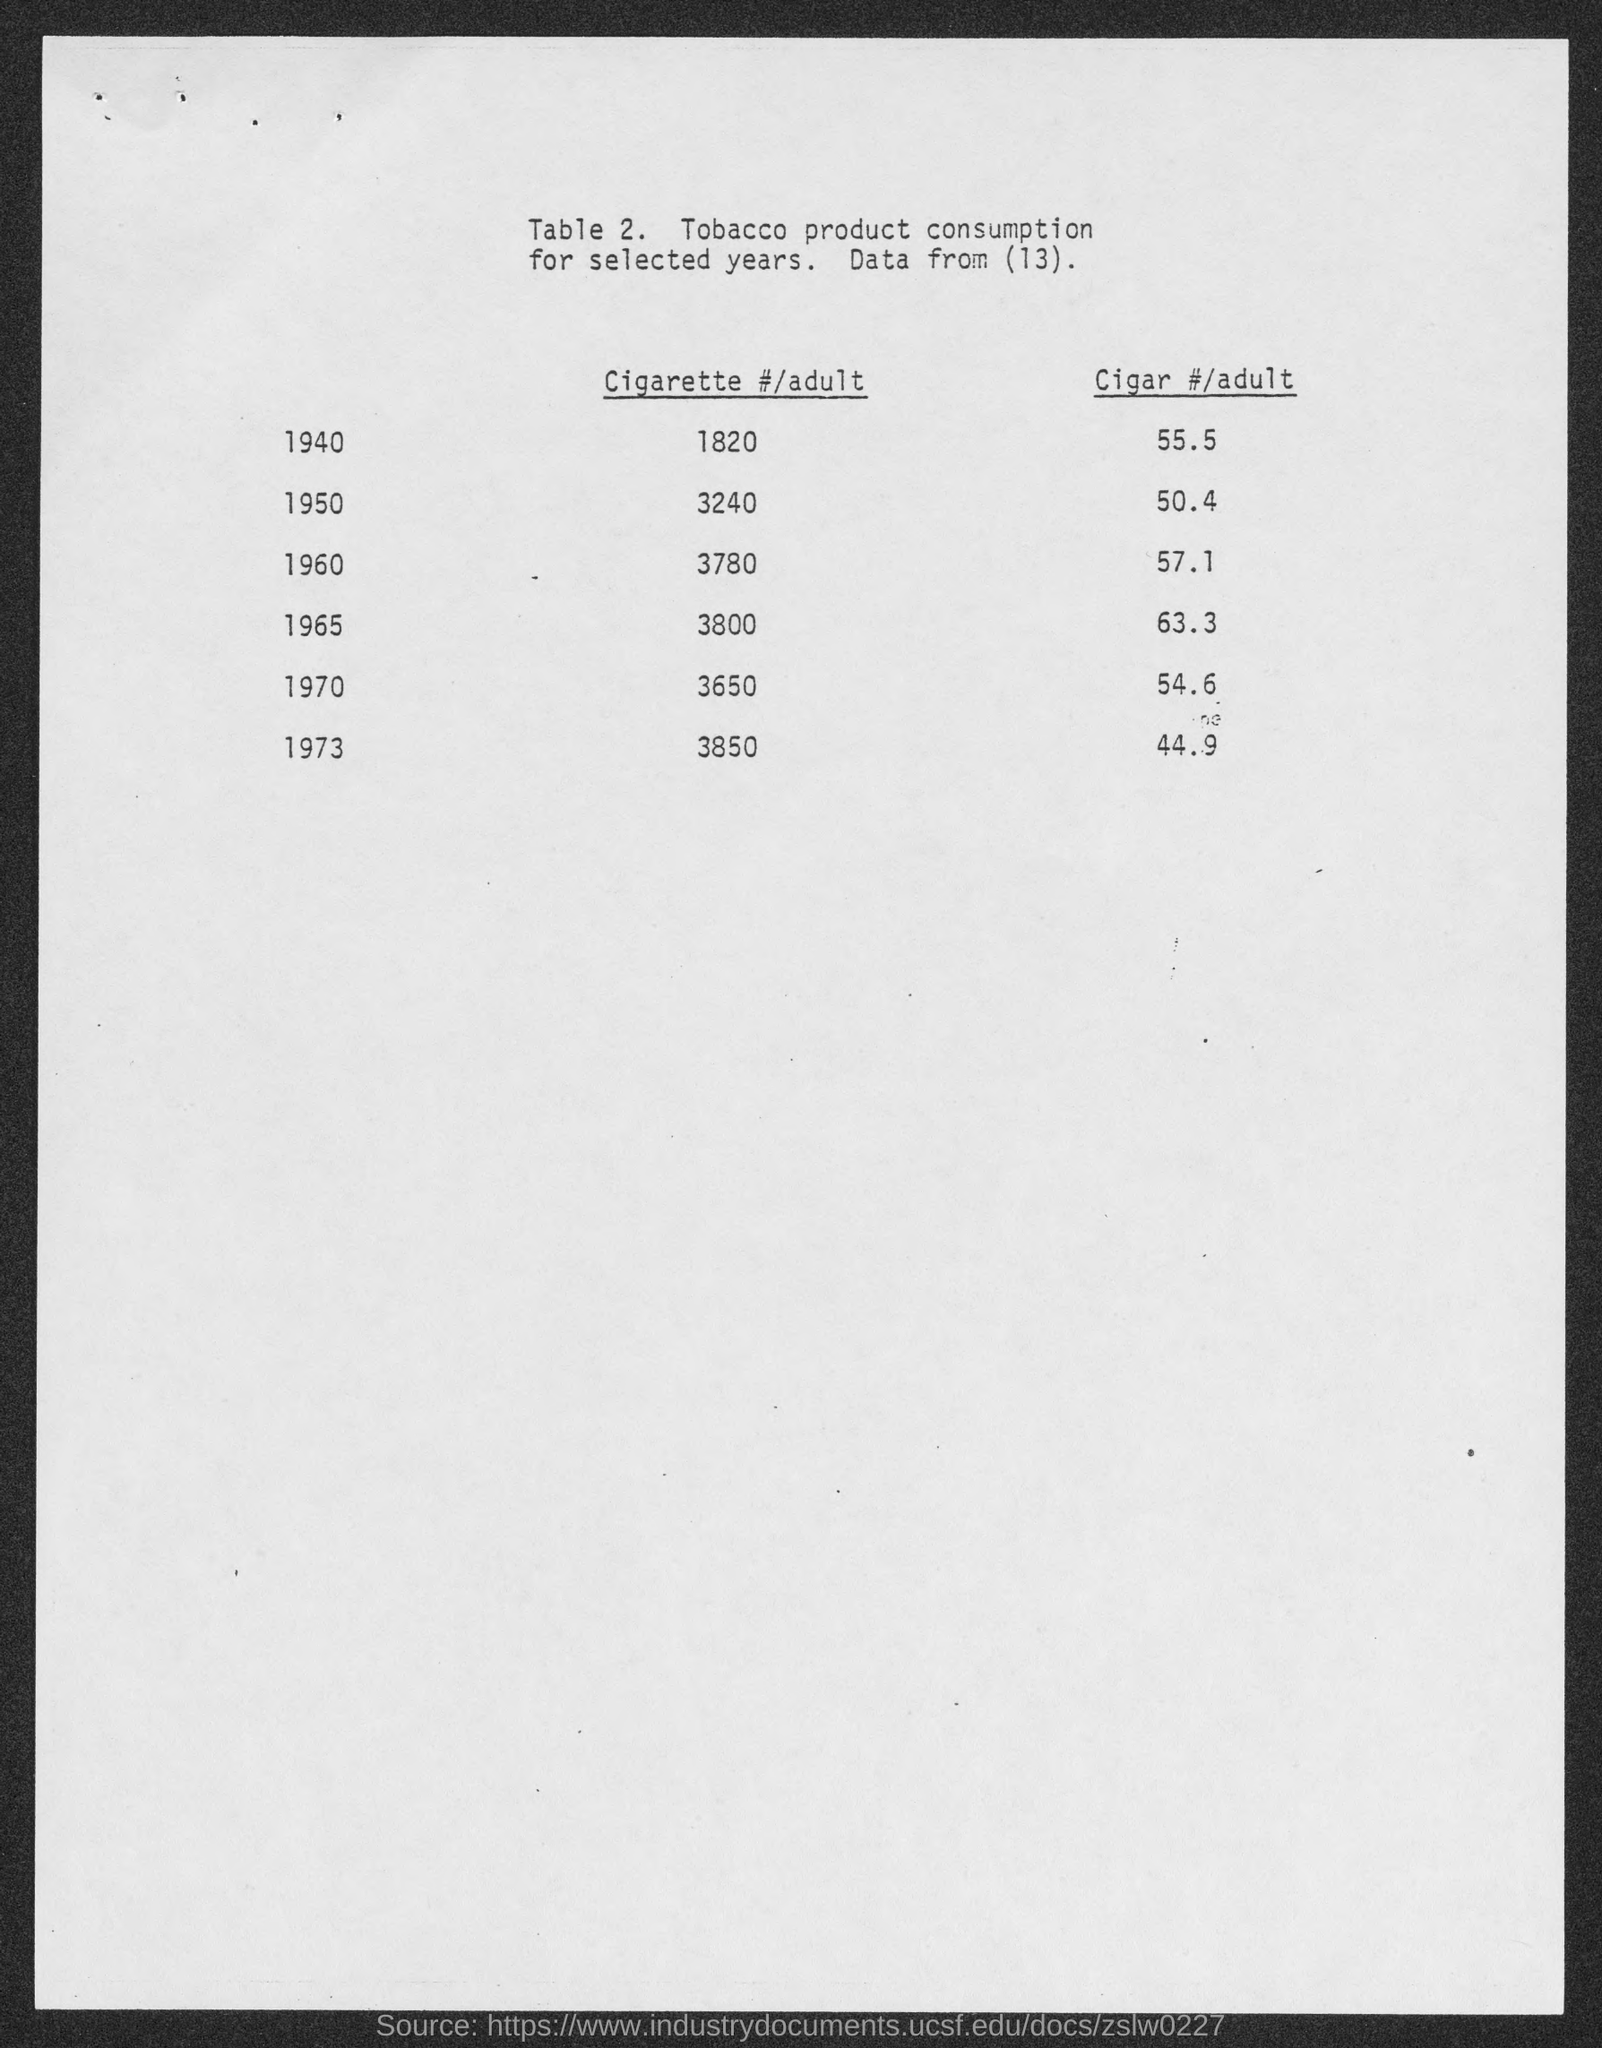List a handful of essential elements in this visual. The table number is?" the person said, gesturing towards Table 2. 